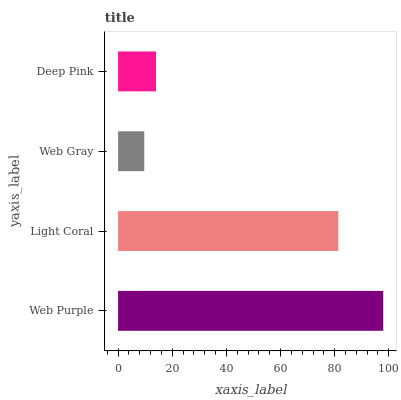Is Web Gray the minimum?
Answer yes or no. Yes. Is Web Purple the maximum?
Answer yes or no. Yes. Is Light Coral the minimum?
Answer yes or no. No. Is Light Coral the maximum?
Answer yes or no. No. Is Web Purple greater than Light Coral?
Answer yes or no. Yes. Is Light Coral less than Web Purple?
Answer yes or no. Yes. Is Light Coral greater than Web Purple?
Answer yes or no. No. Is Web Purple less than Light Coral?
Answer yes or no. No. Is Light Coral the high median?
Answer yes or no. Yes. Is Deep Pink the low median?
Answer yes or no. Yes. Is Deep Pink the high median?
Answer yes or no. No. Is Web Purple the low median?
Answer yes or no. No. 